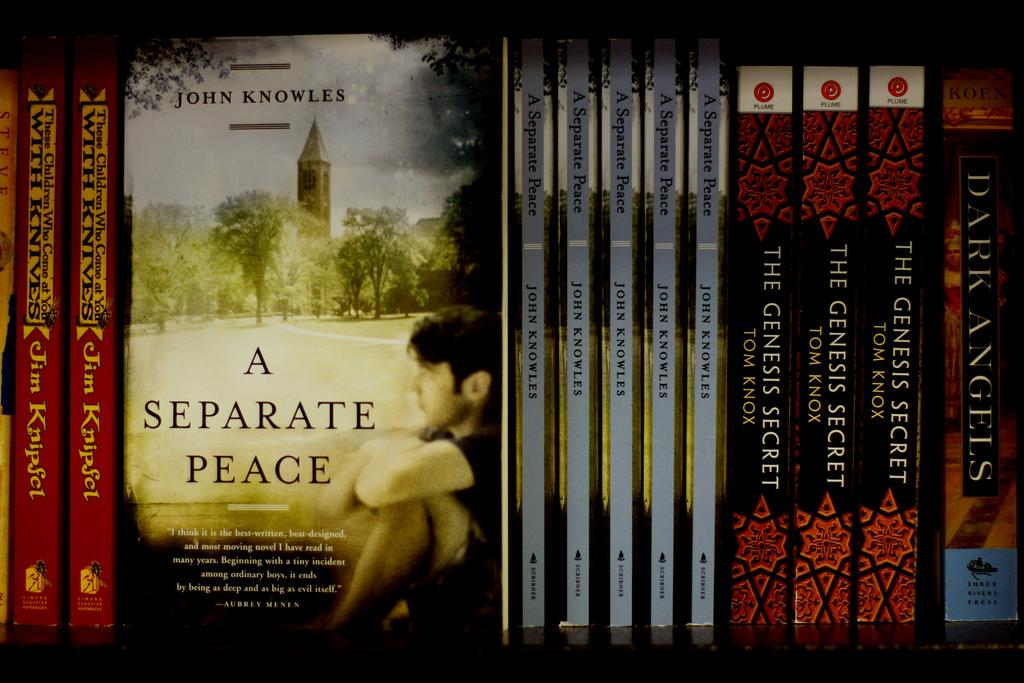<image>
Provide a brief description of the given image. A collection of books with one shown facing titled A Separate Peace. 